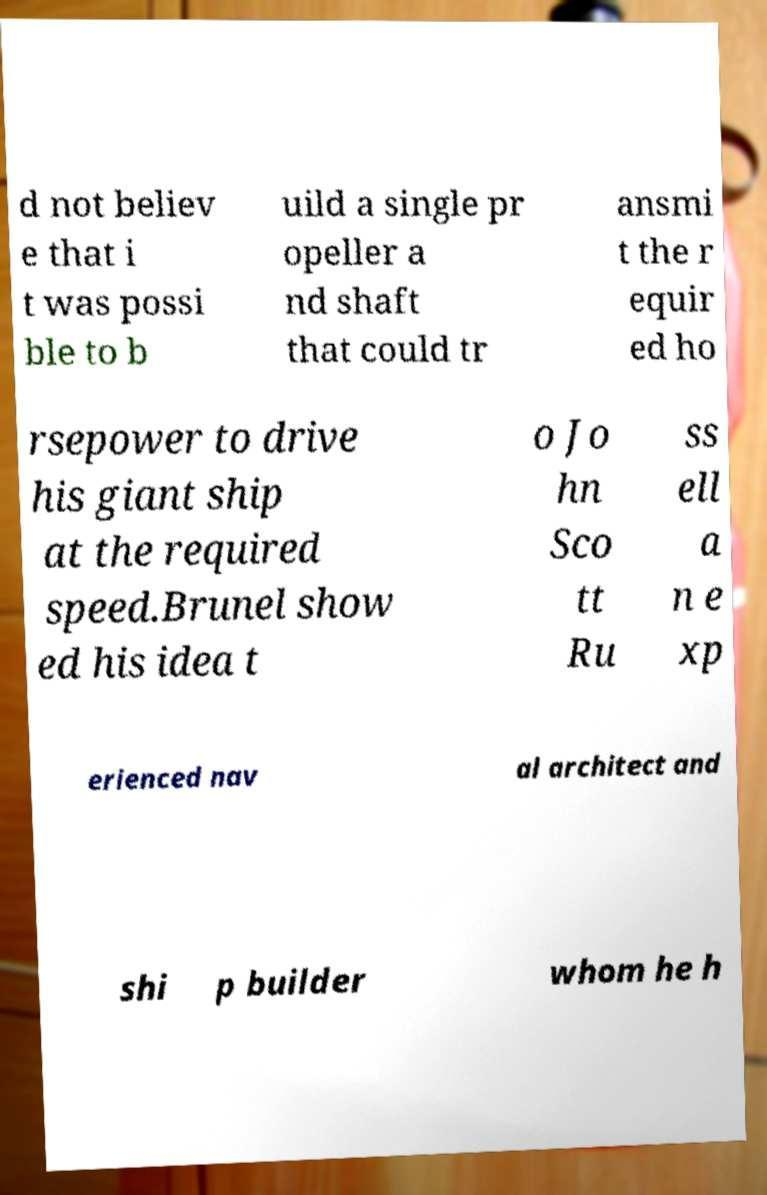Please read and relay the text visible in this image. What does it say? d not believ e that i t was possi ble to b uild a single pr opeller a nd shaft that could tr ansmi t the r equir ed ho rsepower to drive his giant ship at the required speed.Brunel show ed his idea t o Jo hn Sco tt Ru ss ell a n e xp erienced nav al architect and shi p builder whom he h 